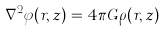<formula> <loc_0><loc_0><loc_500><loc_500>\nabla ^ { 2 } \varphi ( r , z ) = 4 \pi G \rho ( r , z )</formula> 